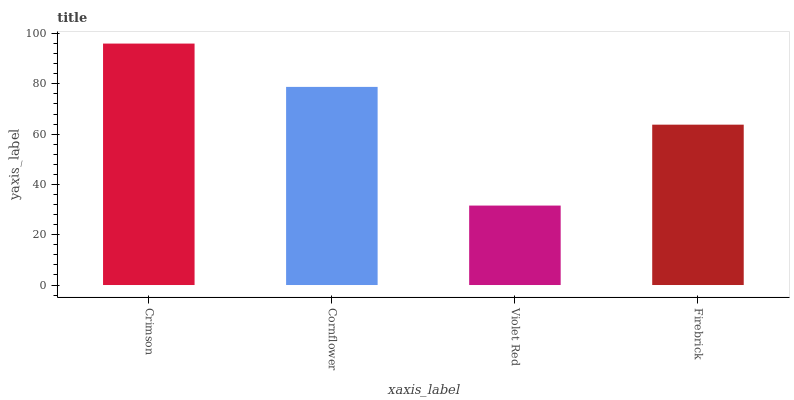Is Cornflower the minimum?
Answer yes or no. No. Is Cornflower the maximum?
Answer yes or no. No. Is Crimson greater than Cornflower?
Answer yes or no. Yes. Is Cornflower less than Crimson?
Answer yes or no. Yes. Is Cornflower greater than Crimson?
Answer yes or no. No. Is Crimson less than Cornflower?
Answer yes or no. No. Is Cornflower the high median?
Answer yes or no. Yes. Is Firebrick the low median?
Answer yes or no. Yes. Is Violet Red the high median?
Answer yes or no. No. Is Crimson the low median?
Answer yes or no. No. 